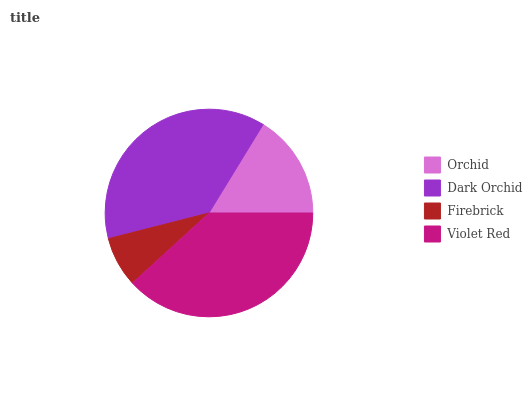Is Firebrick the minimum?
Answer yes or no. Yes. Is Violet Red the maximum?
Answer yes or no. Yes. Is Dark Orchid the minimum?
Answer yes or no. No. Is Dark Orchid the maximum?
Answer yes or no. No. Is Dark Orchid greater than Orchid?
Answer yes or no. Yes. Is Orchid less than Dark Orchid?
Answer yes or no. Yes. Is Orchid greater than Dark Orchid?
Answer yes or no. No. Is Dark Orchid less than Orchid?
Answer yes or no. No. Is Dark Orchid the high median?
Answer yes or no. Yes. Is Orchid the low median?
Answer yes or no. Yes. Is Violet Red the high median?
Answer yes or no. No. Is Dark Orchid the low median?
Answer yes or no. No. 